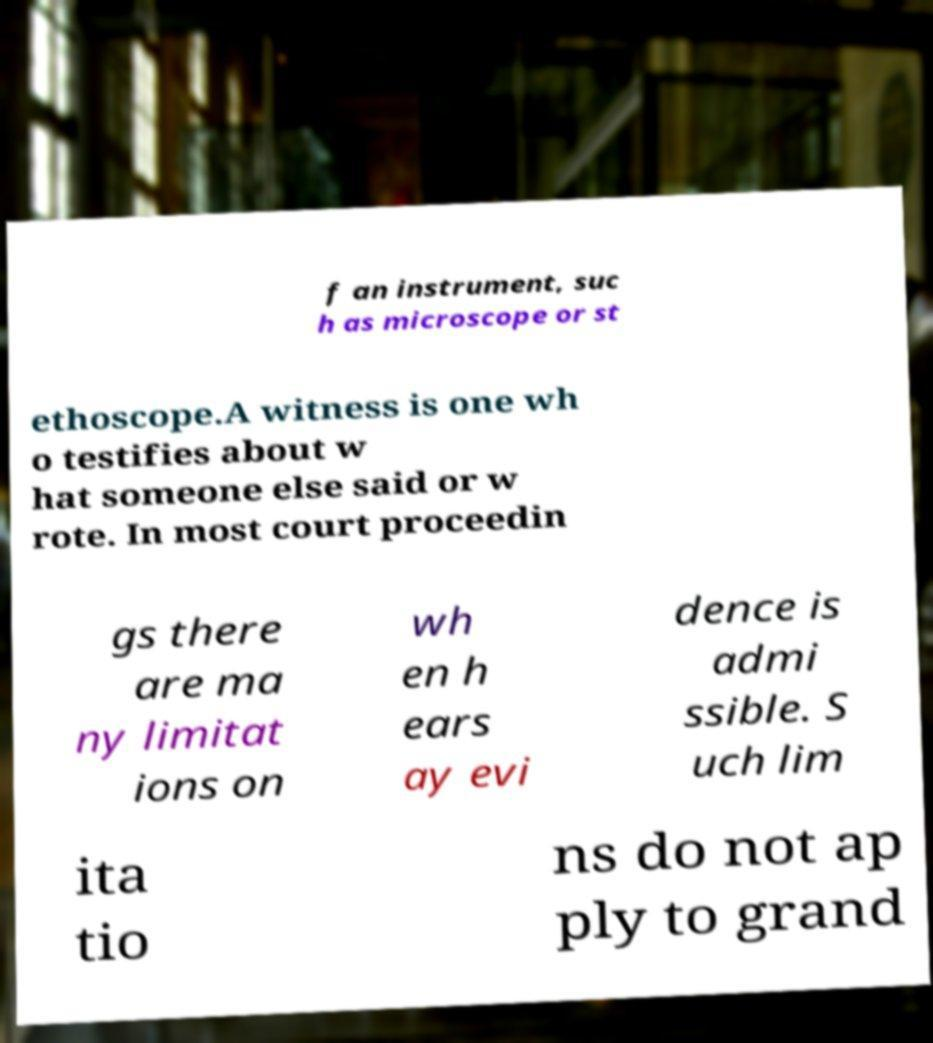I need the written content from this picture converted into text. Can you do that? f an instrument, suc h as microscope or st ethoscope.A witness is one wh o testifies about w hat someone else said or w rote. In most court proceedin gs there are ma ny limitat ions on wh en h ears ay evi dence is admi ssible. S uch lim ita tio ns do not ap ply to grand 